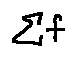Convert formula to latex. <formula><loc_0><loc_0><loc_500><loc_500>\sum f</formula> 